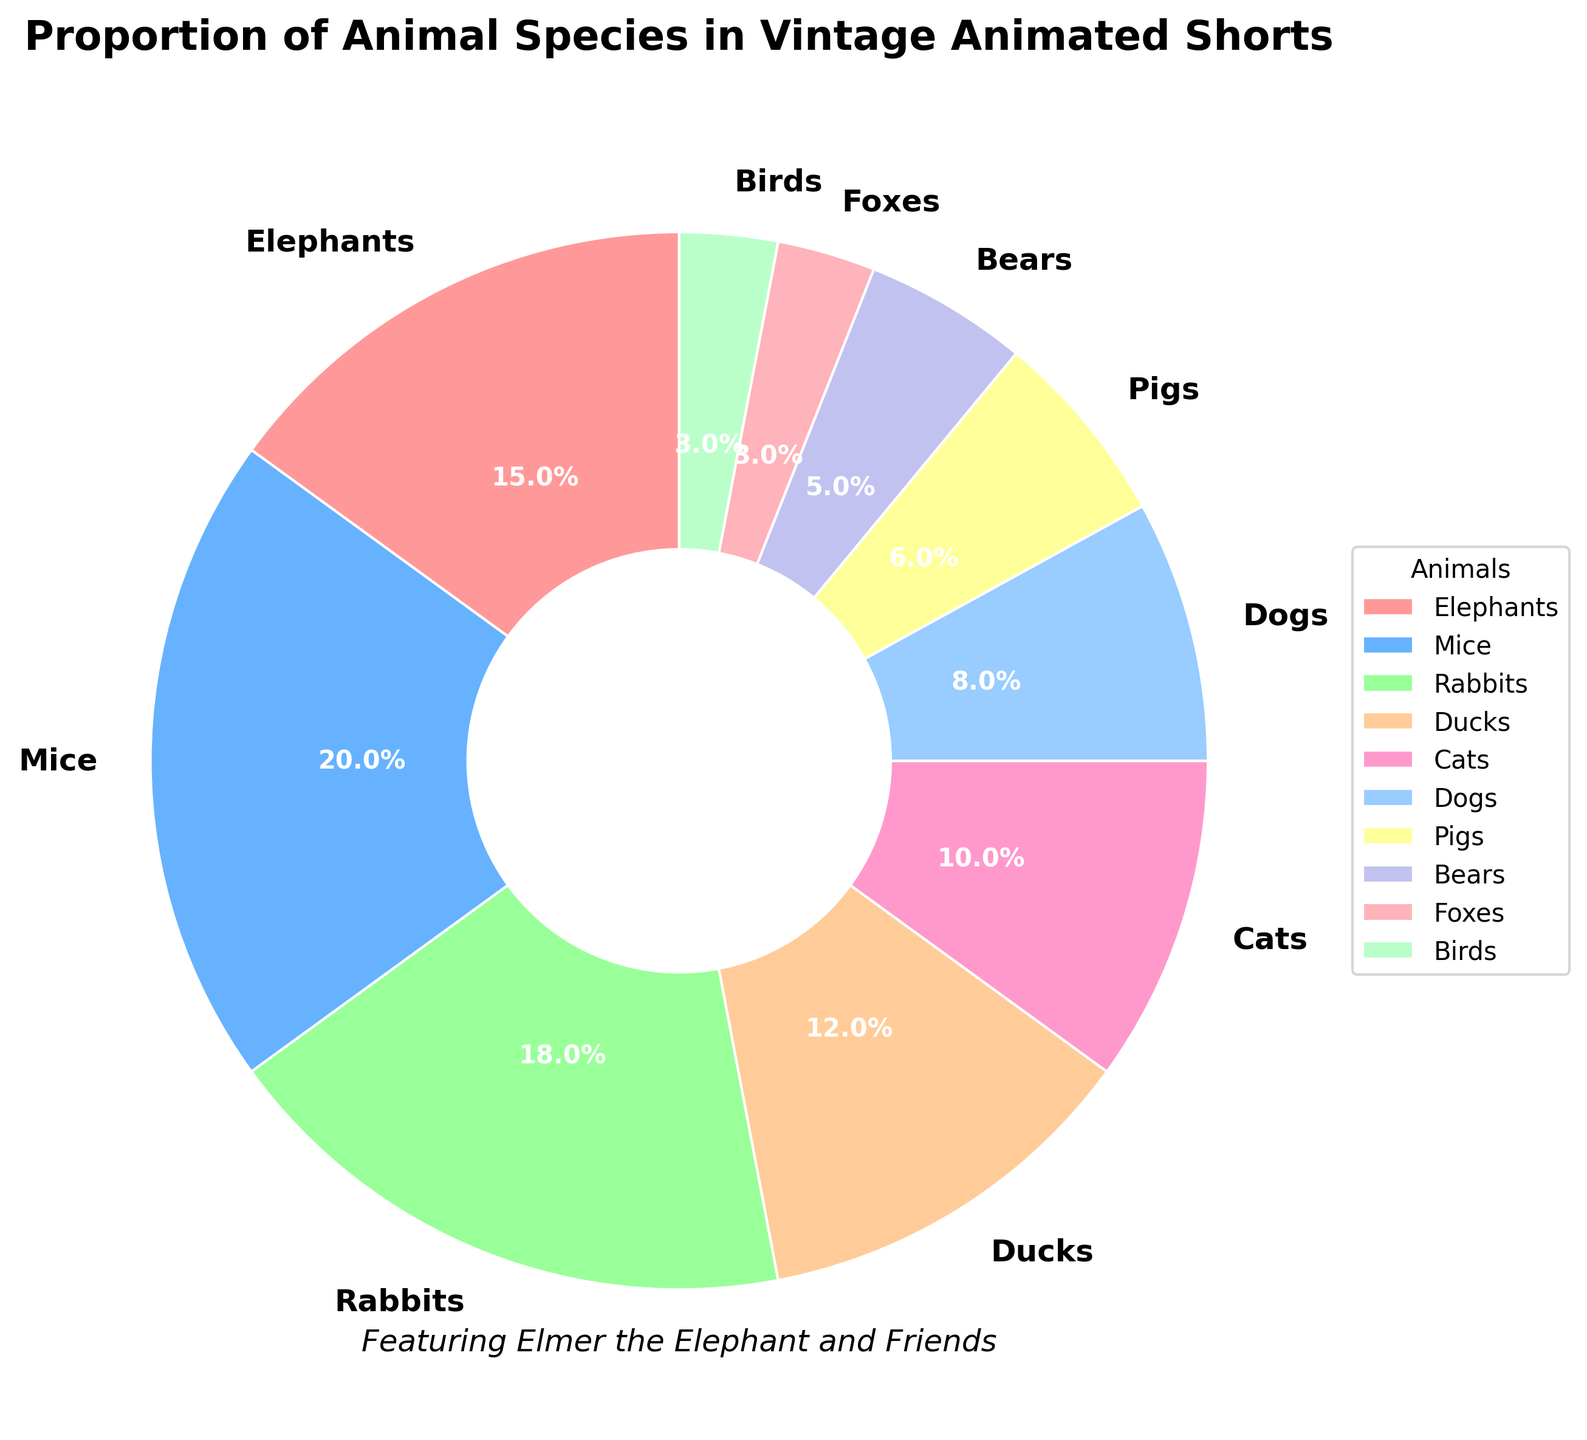Which animal has the highest proportion in vintage animated shorts? Looking at the pie chart, the slice for Mice is the largest, indicating it has the highest proportion.
Answer: Mice What is the combined percentage of Elephants and Ducks? According to the pie chart, Elephants have 15% and Ducks have 12%. Adding them together gives 15% + 12% = 27%.
Answer: 27% How much more percentage do Rabbits have compared to Dogs? Rabbits have 18%, and Dogs have 8%. Subtracting the percentage for Dogs from that of Rabbits gives 18% - 8% = 10%.
Answer: 10% Which animals have equal proportions in the chart? Observing the pie chart, both Foxes and Birds have the same slice size of 3%.
Answer: Foxes and Birds What is the total percentage for Mice, Rabbits, and Cats combined? The pie chart shows Mice with 20%, Rabbits with 18%, and Cats with 10%. Combining these gives 20% + 18% + 10% = 48%.
Answer: 48% Which animal category has a light blue color in the chart? Referring to the colors and corresponding slices, Rabbits are represented by light blue.
Answer: Rabbits What fraction of the total percentage does Dogs and Pigs together constitute? According to the chart, Dogs have 8% and Pigs have 6%. Combined, they total 14%, which as a fraction is 14/100 or simplified to 7/50.
Answer: 7/50 How does the percentage of Ducks compare to that of Elephants? Which one is smaller and by how much percentage? Ducks have 12%, and Elephants have 15%. By comparing these numbers, Ducks have 3% less than Elephants.
Answer: Ducks, 3% If you combine the percentage of Bears, Foxes, and Birds, what is the total? Bears have 5%, Foxes have 3%, and Birds have 3%. Adding these together gives 5% + 3% + 3% = 11%.
Answer: 11% 